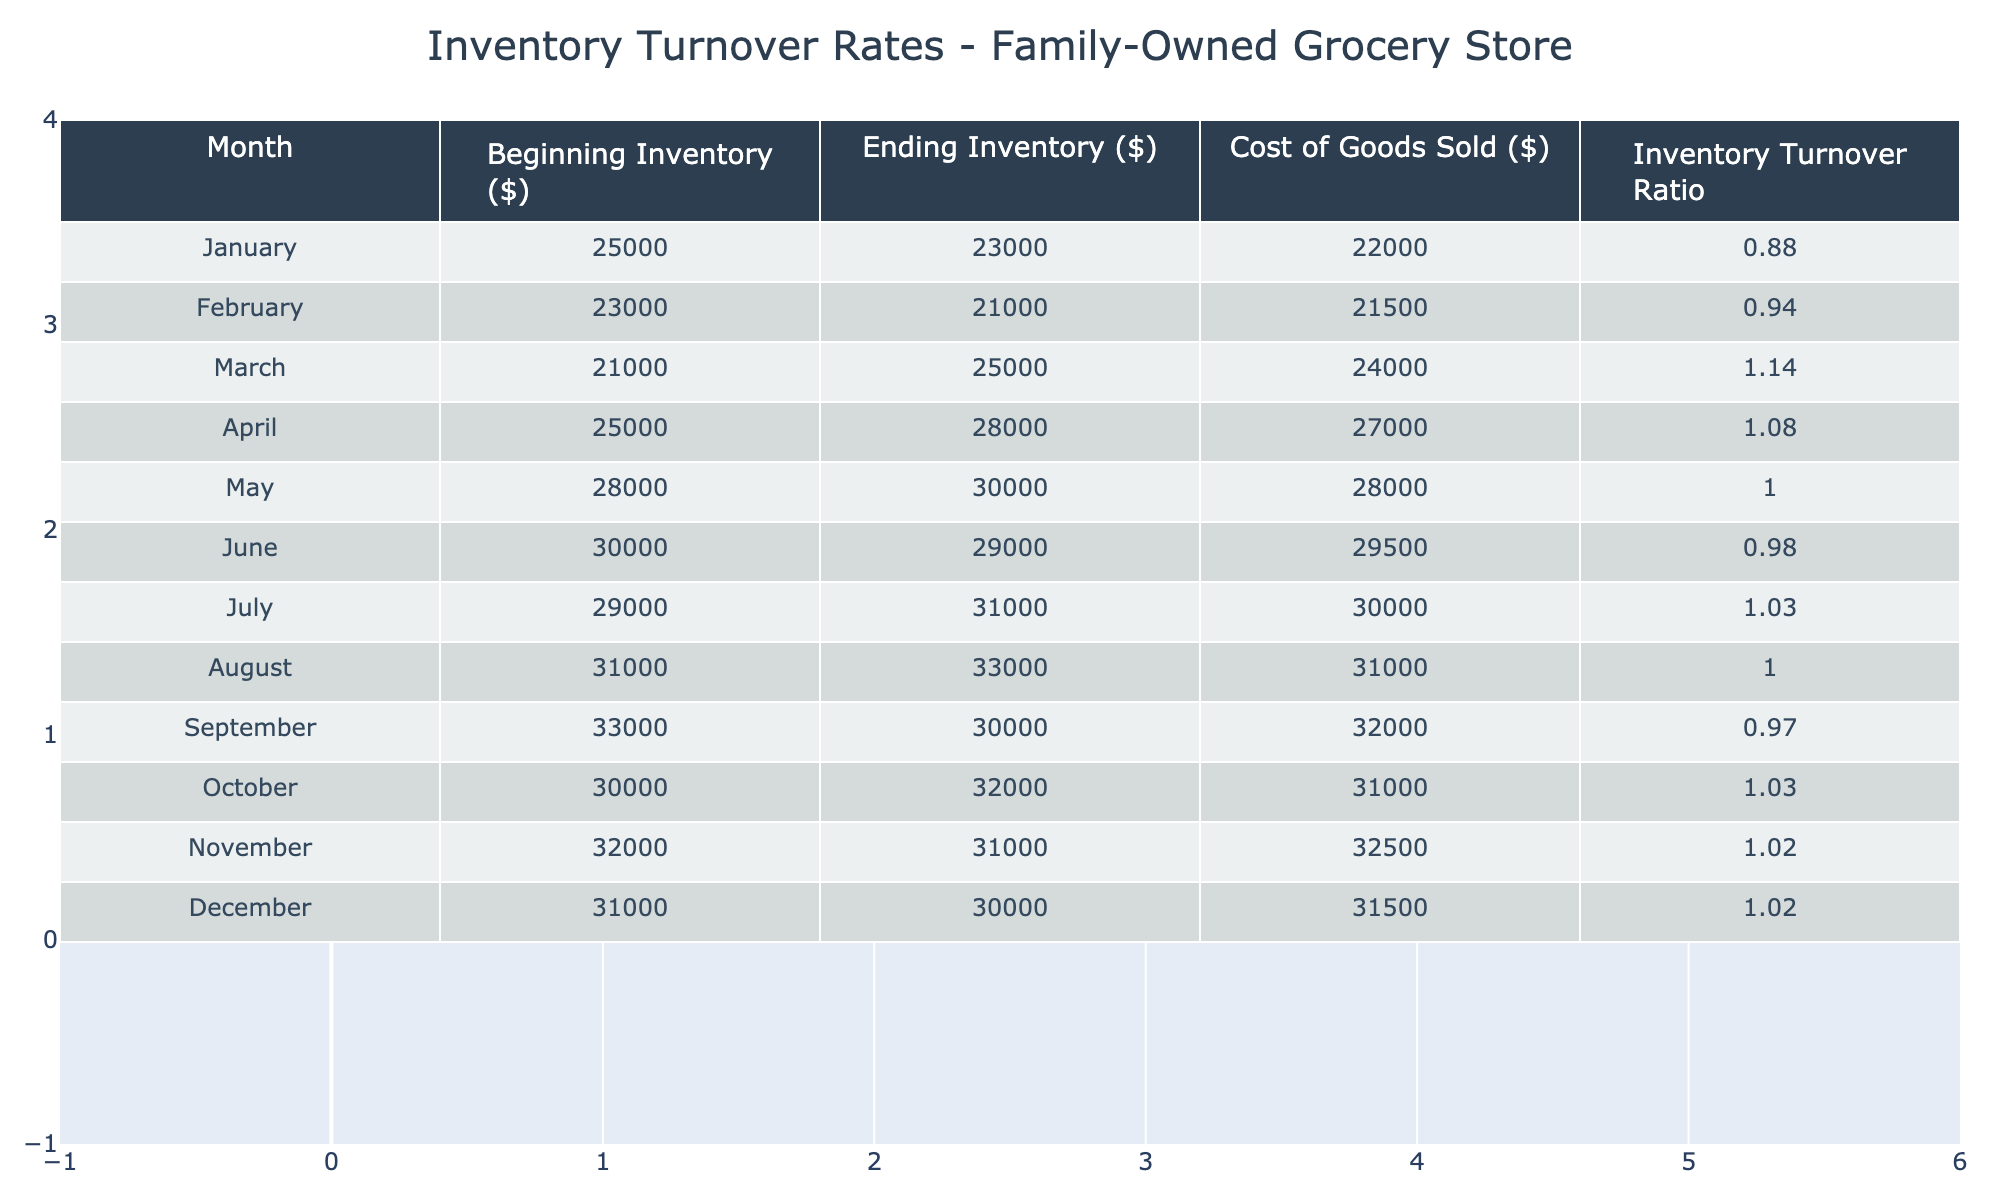What was the inventory turnover ratio in July? In the table, I can find the entry for July in the "Inventory Turnover Ratio" column, which shows a value of 1.03 for that month.
Answer: 1.03 Which month had the highest cost of goods sold? Looking at the "Cost of Goods Sold" column, the values are 22000, 21500, 24000, 27000, 28000, 29500, 30000, 31000, 32000, 31000, 32500, and 31500 across all months. The highest value is 32500 in November.
Answer: November What is the average beginning inventory for the year? To find the average beginning inventory, I will sum the beginning inventory values: (25000 + 23000 + 21000 + 25000 + 28000 + 30000 + 29000 + 31000 + 33000 + 30000 + 32000 + 31000) = 353000. There are 12 months, so the average is 353000 / 12 = 29416.67.
Answer: 29416.67 Did the inventory turnover ratio increase from March to April? The inventory turnover ratio for March is 1.14 and for April is 1.08. Since 1.08 is less than 1.14, it indicates a decrease.
Answer: No Which month had the largest change in ending inventory compared to the beginning inventory? I need to calculate the change for each month by taking the difference between the beginning and ending inventory for each month. The changes are: January (-2000), February (-2000), March (+4000), April (+3000), May (+2000), June (-1000), July (+2000), August (+2000), September (-3000), October (+2000), November (-1000), and December (-1000). The largest change is +4000 in March.
Answer: March Is there a correlation between the cost of goods sold and the inventory turnover ratio? To determine if there is a correlation, I can compare the values in both columns. While it requires statistical analysis, I can note that as cost of goods sold fluctuates, the inventory turnover ratio tends to vary as well, suggesting a potential relationship, although a direct calculation is needed for confirmation.
Answer: Yes, likely correlation What was the ending inventory in October? October's entry in the "Ending Inventory" column shows a value of 32000.
Answer: 32000 What was the total cost of goods sold for the year? To find the total cost of goods sold for the year, I sum all values from the "Cost of Goods Sold" column: (22000 + 21500 + 24000 + 27000 + 28000 + 29500 + 30000 + 31000 + 32000 + 31000 + 32500 + 31500) = 356500.
Answer: 356500 